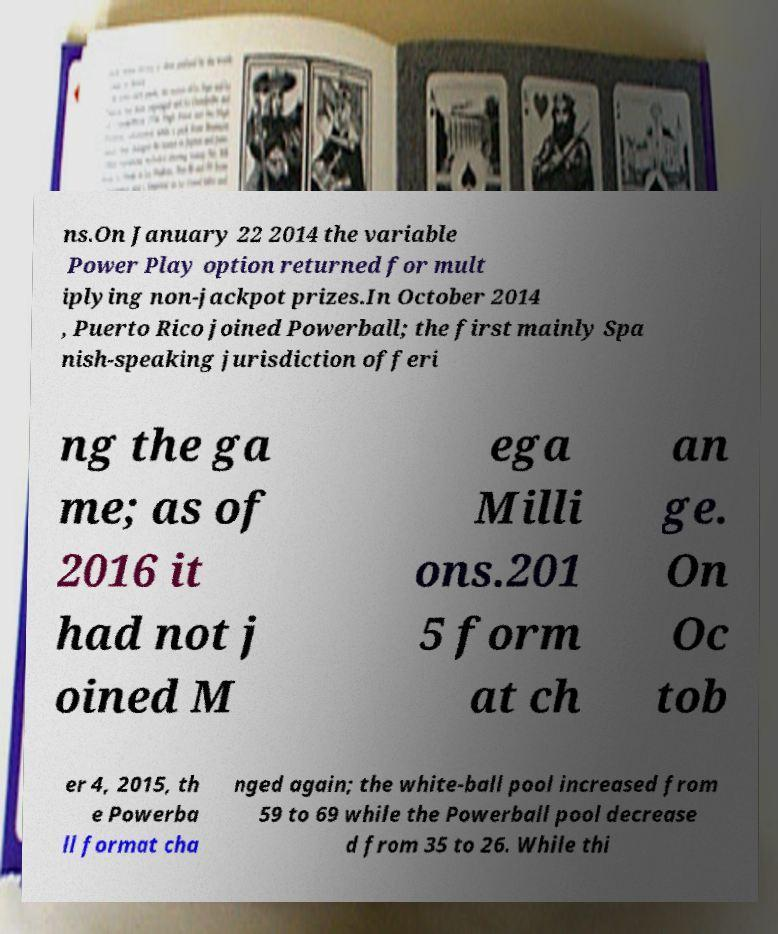There's text embedded in this image that I need extracted. Can you transcribe it verbatim? ns.On January 22 2014 the variable Power Play option returned for mult iplying non-jackpot prizes.In October 2014 , Puerto Rico joined Powerball; the first mainly Spa nish-speaking jurisdiction offeri ng the ga me; as of 2016 it had not j oined M ega Milli ons.201 5 form at ch an ge. On Oc tob er 4, 2015, th e Powerba ll format cha nged again; the white-ball pool increased from 59 to 69 while the Powerball pool decrease d from 35 to 26. While thi 